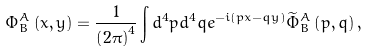Convert formula to latex. <formula><loc_0><loc_0><loc_500><loc_500>\Phi _ { B } ^ { A } \left ( x , y \right ) = \frac { 1 } { \left ( 2 \pi \right ) ^ { 4 } } \int d ^ { 4 } p d ^ { 4 } q e ^ { - i \left ( p x - q y \right ) } \widetilde { \Phi } _ { B } ^ { A } \left ( p , q \right ) ,</formula> 